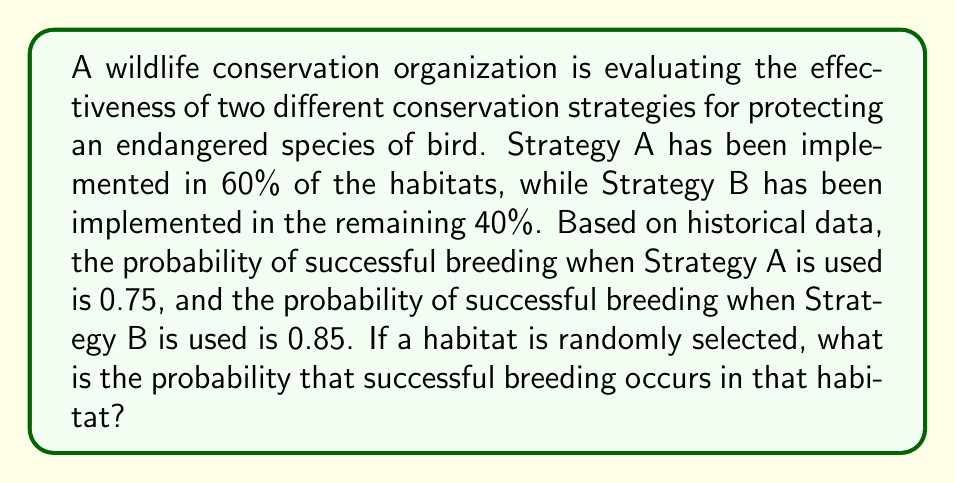What is the answer to this math problem? To solve this problem, we'll use the law of total probability. Let's break it down step by step:

1. Define events:
   - Let A be the event that Strategy A is used
   - Let B be the event that Strategy B is used
   - Let S be the event of successful breeding

2. Given probabilities:
   - P(A) = 0.60 (60% of habitats use Strategy A)
   - P(B) = 0.40 (40% of habitats use Strategy B)
   - P(S|A) = 0.75 (probability of success given Strategy A)
   - P(S|B) = 0.85 (probability of success given Strategy B)

3. Use the law of total probability:
   $$P(S) = P(S|A) \cdot P(A) + P(S|B) \cdot P(B)$$

4. Substitute the values:
   $$P(S) = 0.75 \cdot 0.60 + 0.85 \cdot 0.40$$

5. Calculate:
   $$P(S) = 0.45 + 0.34 = 0.79$$

Therefore, the probability of successful breeding in a randomly selected habitat is 0.79 or 79%.
Answer: 0.79 or 79% 